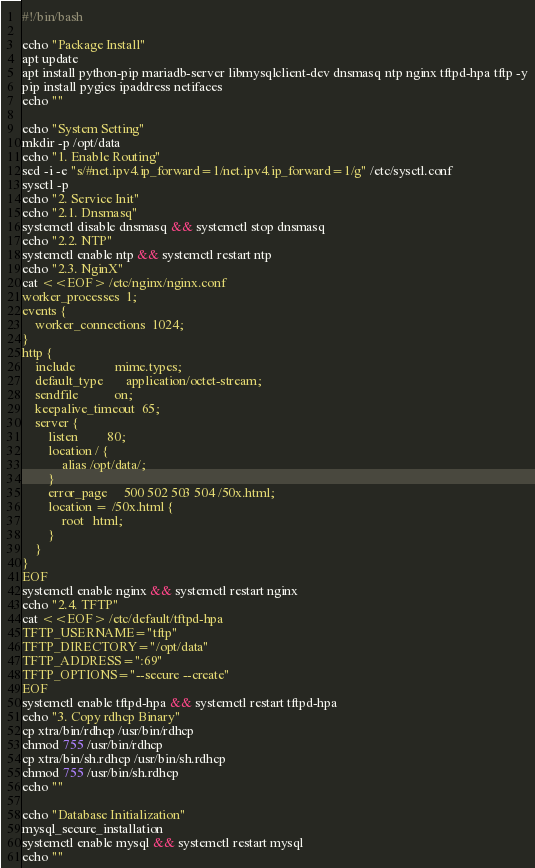<code> <loc_0><loc_0><loc_500><loc_500><_Bash_>#!/bin/bash

echo "Package Install"
apt update
apt install python-pip mariadb-server libmysqlclient-dev dnsmasq ntp nginx tftpd-hpa tftp -y
pip install pygics ipaddress netifaces
echo ""

echo "System Setting"
mkdir -p /opt/data
echo "1. Enable Routing"
sed -i -e "s/#net.ipv4.ip_forward=1/net.ipv4.ip_forward=1/g" /etc/sysctl.conf
sysctl -p
echo "2. Service Init"
echo "2.1. Dnsmasq"
systemctl disable dnsmasq && systemctl stop dnsmasq
echo "2.2. NTP"
systemctl enable ntp && systemctl restart ntp
echo "2.3. NginX"
cat <<EOF> /etc/nginx/nginx.conf
worker_processes  1;
events {
    worker_connections  1024;
}
http {
    include            mime.types;
    default_type       application/octet-stream;
    sendfile           on;
    keepalive_timeout  65;
    server {
        listen         80;
        location / {
            alias /opt/data/;
        }
        error_page     500 502 503 504 /50x.html;
        location = /50x.html {
            root   html;
        }
    }
}
EOF
systemctl enable nginx && systemctl restart nginx
echo "2.4. TFTP"
cat <<EOF> /etc/default/tftpd-hpa
TFTP_USERNAME="tftp"
TFTP_DIRECTORY="/opt/data"
TFTP_ADDRESS=":69"
TFTP_OPTIONS="--secure --create"
EOF
systemctl enable tftpd-hpa && systemctl restart tftpd-hpa
echo "3. Copy rdhcp Binary"
cp xtra/bin/rdhcp /usr/bin/rdhcp
chmod 755 /usr/bin/rdhcp
cp xtra/bin/sh.rdhcp /usr/bin/sh.rdhcp
chmod 755 /usr/bin/sh.rdhcp
echo ""

echo "Database Initialization"
mysql_secure_installation
systemctl enable mysql && systemctl restart mysql
echo ""

</code> 